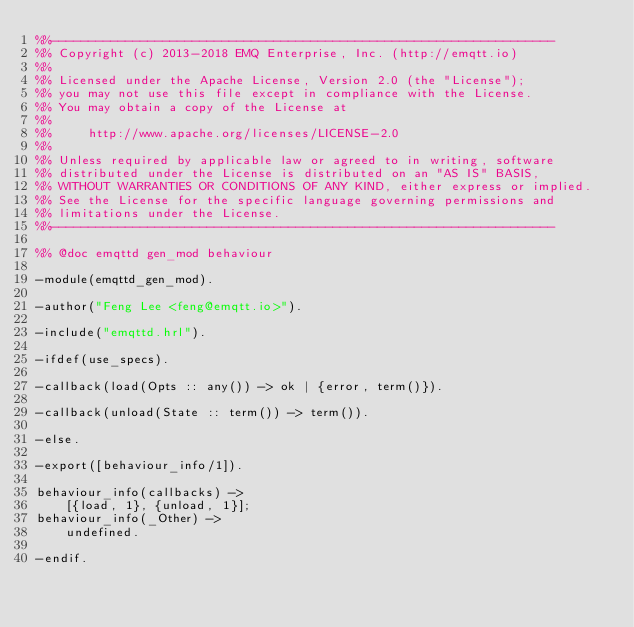<code> <loc_0><loc_0><loc_500><loc_500><_Erlang_>%%--------------------------------------------------------------------
%% Copyright (c) 2013-2018 EMQ Enterprise, Inc. (http://emqtt.io)
%%
%% Licensed under the Apache License, Version 2.0 (the "License");
%% you may not use this file except in compliance with the License.
%% You may obtain a copy of the License at
%%
%%     http://www.apache.org/licenses/LICENSE-2.0
%%
%% Unless required by applicable law or agreed to in writing, software
%% distributed under the License is distributed on an "AS IS" BASIS,
%% WITHOUT WARRANTIES OR CONDITIONS OF ANY KIND, either express or implied.
%% See the License for the specific language governing permissions and
%% limitations under the License.
%%--------------------------------------------------------------------

%% @doc emqttd gen_mod behaviour

-module(emqttd_gen_mod).

-author("Feng Lee <feng@emqtt.io>").

-include("emqttd.hrl").

-ifdef(use_specs).

-callback(load(Opts :: any()) -> ok | {error, term()}).

-callback(unload(State :: term()) -> term()).

-else.

-export([behaviour_info/1]).

behaviour_info(callbacks) ->
    [{load, 1}, {unload, 1}];
behaviour_info(_Other) ->
    undefined.

-endif.
</code> 